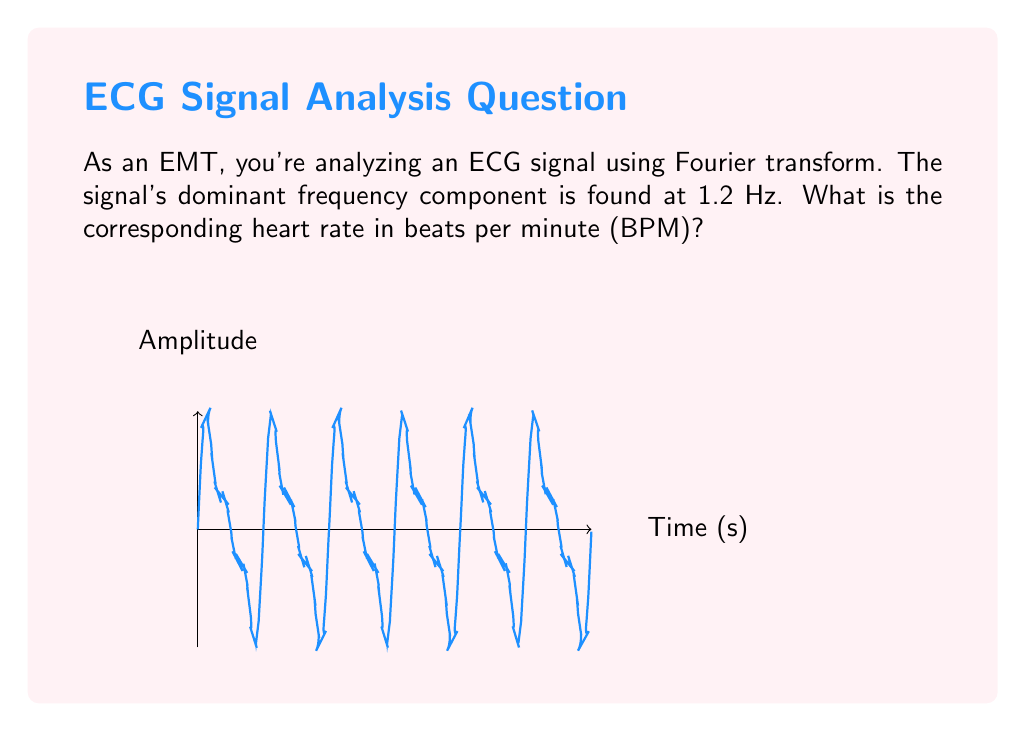What is the answer to this math problem? To solve this problem, we need to follow these steps:

1) The Fourier transform has revealed that the dominant frequency of the ECG signal is 1.2 Hz.

2) Frequency (f) is the number of cycles per second. In this case:

   $f = 1.2$ Hz = 1.2 cycles/second

3) To convert this to beats per minute (BPM), we need to:
   a) Convert seconds to minutes
   b) Convert cycles to beats

4) There are 60 seconds in a minute, so we multiply by 60:

   $\text{BPM} = 1.2 \text{ cycles/second} \times 60 \text{ seconds/minute}$

5) Simplifying:

   $\text{BPM} = 1.2 \times 60 = 72$

6) Each cycle of the ECG represents one heartbeat, so cycles directly translate to beats.

Therefore, a dominant frequency of 1.2 Hz corresponds to a heart rate of 72 BPM.
Answer: 72 BPM 